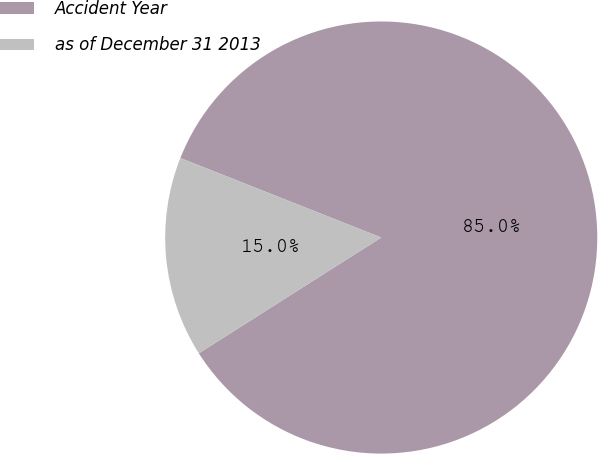<chart> <loc_0><loc_0><loc_500><loc_500><pie_chart><fcel>Accident Year<fcel>as of December 31 2013<nl><fcel>85.0%<fcel>15.0%<nl></chart> 